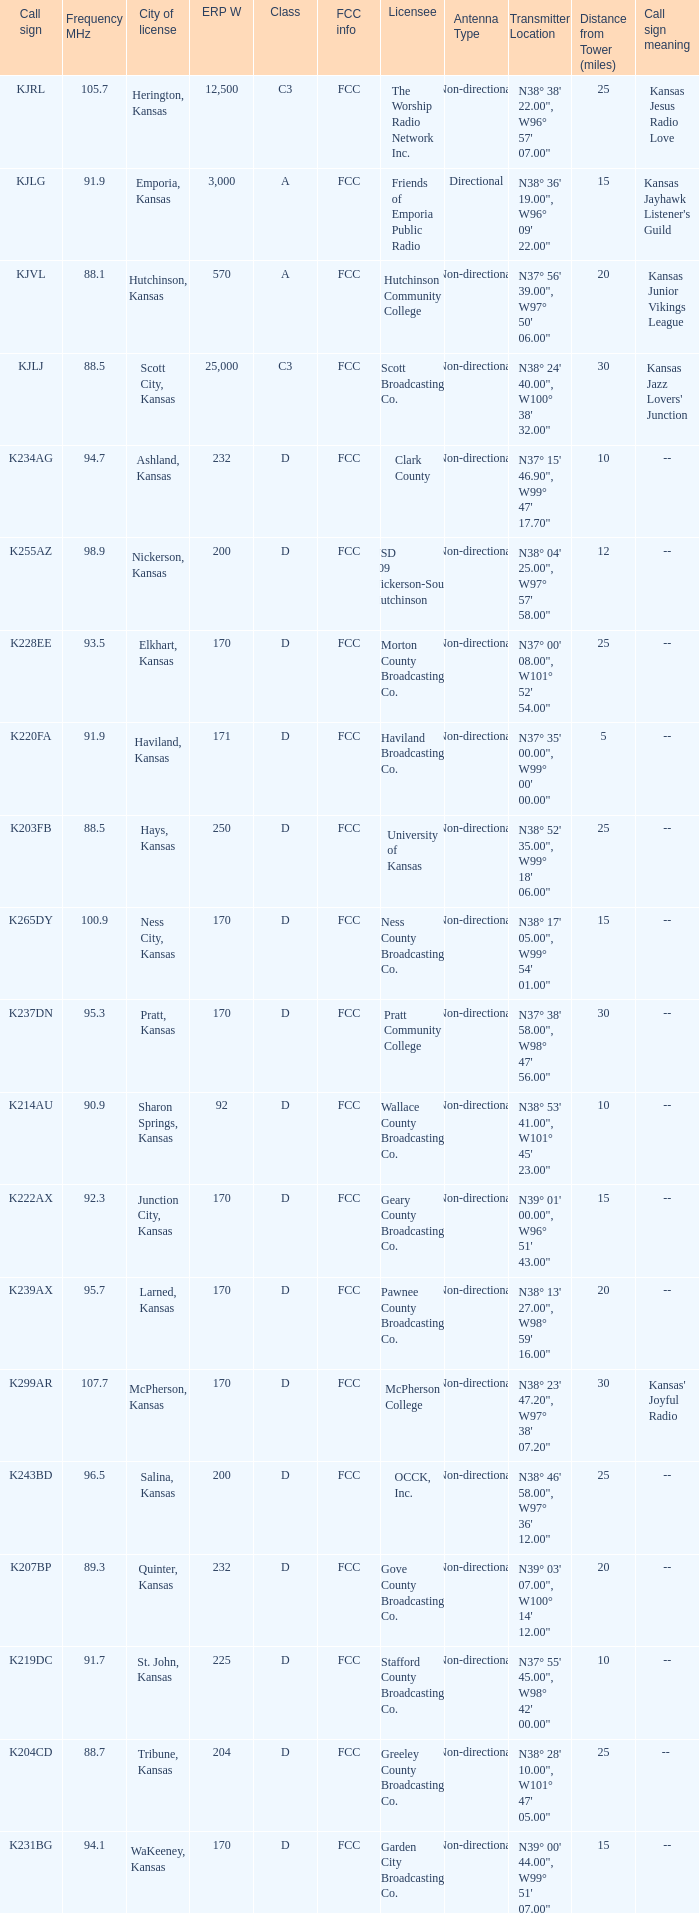Frequency MHz of 88.7 had what average erp w? 204.0. Parse the table in full. {'header': ['Call sign', 'Frequency MHz', 'City of license', 'ERP W', 'Class', 'FCC info', 'Licensee', 'Antenna Type', 'Transmitter Location', 'Distance from Tower (miles)', 'Call sign meaning'], 'rows': [['KJRL', '105.7', 'Herington, Kansas', '12,500', 'C3', 'FCC', 'The Worship Radio Network Inc.', 'Non-directional', 'N38° 38\' 22.00", W96° 57\' 07.00"', '25', 'Kansas Jesus Radio Love'], ['KJLG', '91.9', 'Emporia, Kansas', '3,000', 'A', 'FCC', 'Friends of Emporia Public Radio', 'Directional', 'N38° 36\' 19.00", W96° 09\' 22.00"', '15', "Kansas Jayhawk Listener's Guild "], ['KJVL', '88.1', 'Hutchinson, Kansas', '570', 'A', 'FCC', 'Hutchinson Community College', 'Non-directional', 'N37° 56\' 39.00", W97° 50\' 06.00"', '20', 'Kansas Junior Vikings League'], ['KJLJ', '88.5', 'Scott City, Kansas', '25,000', 'C3', 'FCC', 'Scott Broadcasting Co.', 'Non-directional', 'N38° 24\' 40.00", W100° 38\' 32.00"', '30', "Kansas Jazz Lovers' Junction"], ['K234AG', '94.7', 'Ashland, Kansas', '232', 'D', 'FCC', 'Clark County', 'Non-directional', 'N37° 15\' 46.90", W99° 47\' 17.70"', '10', '--'], ['K255AZ', '98.9', 'Nickerson, Kansas', '200', 'D', 'FCC', 'USD 309 Nickerson-South Hutchinson', 'Non-directional', 'N38° 04\' 25.00", W97° 57\' 58.00"', '12', '--'], ['K228EE', '93.5', 'Elkhart, Kansas', '170', 'D', 'FCC', 'Morton County Broadcasting Co.', 'Non-directional', 'N37° 00\' 08.00", W101° 52\' 54.00"', '25', '--'], ['K220FA', '91.9', 'Haviland, Kansas', '171', 'D', 'FCC', 'Haviland Broadcasting Co.', 'Non-directional', 'N37° 35\' 00.00", W99° 00\' 00.00"', '5', '--'], ['K203FB', '88.5', 'Hays, Kansas', '250', 'D', 'FCC', 'University of Kansas', 'Non-directional', 'N38° 52\' 35.00", W99° 18\' 06.00"', '25', '--'], ['K265DY', '100.9', 'Ness City, Kansas', '170', 'D', 'FCC', 'Ness County Broadcasting Co.', 'Non-directional', 'N38° 17\' 05.00", W99° 54\' 01.00"', '15', '--'], ['K237DN', '95.3', 'Pratt, Kansas', '170', 'D', 'FCC', 'Pratt Community College', 'Non-directional', 'N37° 38\' 58.00", W98° 47\' 56.00"', '30', '--'], ['K214AU', '90.9', 'Sharon Springs, Kansas', '92', 'D', 'FCC', 'Wallace County Broadcasting Co.', 'Non-directional', 'N38° 53\' 41.00", W101° 45\' 23.00"', '10', '--'], ['K222AX', '92.3', 'Junction City, Kansas', '170', 'D', 'FCC', 'Geary County Broadcasting Co.', 'Non-directional', 'N39° 01\' 00.00", W96° 51\' 43.00"', '15', '--'], ['K239AX', '95.7', 'Larned, Kansas', '170', 'D', 'FCC', 'Pawnee County Broadcasting Co.', 'Non-directional', 'N38° 13\' 27.00", W98° 59\' 16.00"', '20', '--'], ['K299AR', '107.7', 'McPherson, Kansas', '170', 'D', 'FCC', 'McPherson College', 'Non-directional', 'N38° 23\' 47.20", W97° 38\' 07.20"', '30', "Kansas' Joyful Radio"], ['K243BD', '96.5', 'Salina, Kansas', '200', 'D', 'FCC', 'OCCK, Inc.', 'Non-directional', 'N38° 46\' 58.00", W97° 36\' 12.00"', '25', '--'], ['K207BP', '89.3', 'Quinter, Kansas', '232', 'D', 'FCC', 'Gove County Broadcasting Co.', 'Non-directional', 'N39° 03\' 07.00", W100° 14\' 12.00"', '20', '--'], ['K219DC', '91.7', 'St. John, Kansas', '225', 'D', 'FCC', 'Stafford County Broadcasting Co.', 'Non-directional', 'N37° 55\' 45.00", W98° 42\' 00.00"', '10', '--'], ['K204CD', '88.7', 'Tribune, Kansas', '204', 'D', 'FCC', 'Greeley County Broadcasting Co.', 'Non-directional', 'N38° 28\' 10.00", W101° 47\' 05.00"', '25', '-- '], ['K231BG', '94.1', 'WaKeeney, Kansas', '170', 'D', 'FCC', 'Garden City Broadcasting Co.', 'Non-directional', 'N39° 00\' 44.00", W99° 51\' 07.00"', '15', '--']]} 